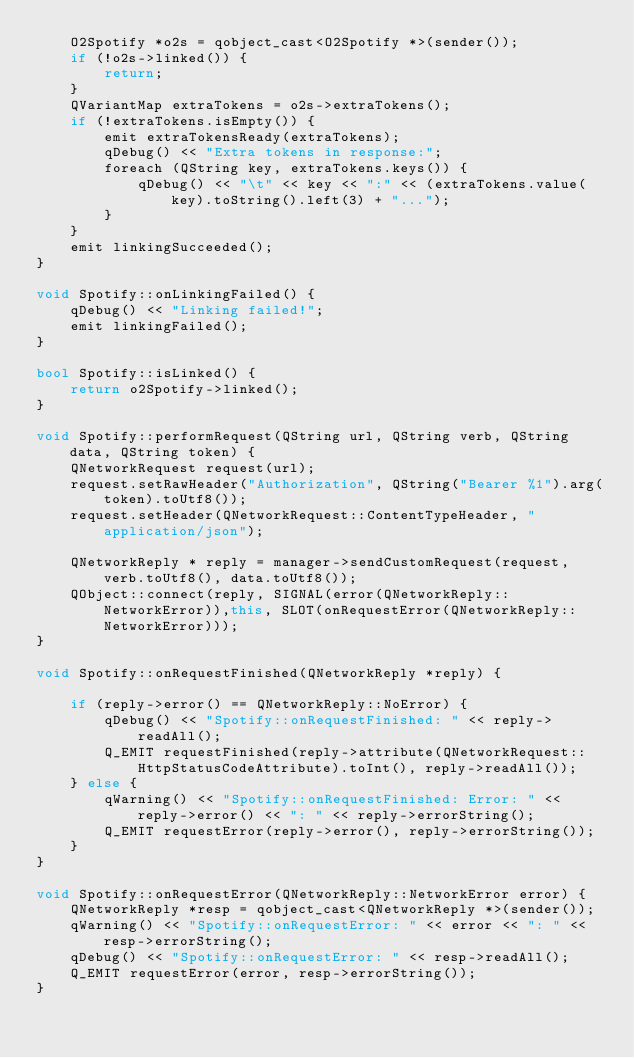Convert code to text. <code><loc_0><loc_0><loc_500><loc_500><_C++_>    O2Spotify *o2s = qobject_cast<O2Spotify *>(sender());
    if (!o2s->linked()) {
        return;
    }
    QVariantMap extraTokens = o2s->extraTokens();
    if (!extraTokens.isEmpty()) {
        emit extraTokensReady(extraTokens);
        qDebug() << "Extra tokens in response:";
        foreach (QString key, extraTokens.keys()) {
            qDebug() << "\t" << key << ":" << (extraTokens.value(key).toString().left(3) + "...");
        }
    }
    emit linkingSucceeded();
}

void Spotify::onLinkingFailed() {
    qDebug() << "Linking failed!";
    emit linkingFailed();
}

bool Spotify::isLinked() {
    return o2Spotify->linked();
}

void Spotify::performRequest(QString url, QString verb, QString data, QString token) {
    QNetworkRequest request(url);
    request.setRawHeader("Authorization", QString("Bearer %1").arg(token).toUtf8());
    request.setHeader(QNetworkRequest::ContentTypeHeader, "application/json");
    
    QNetworkReply * reply = manager->sendCustomRequest(request, verb.toUtf8(), data.toUtf8());
    QObject::connect(reply, SIGNAL(error(QNetworkReply::NetworkError)),this, SLOT(onRequestError(QNetworkReply::NetworkError)));
}

void Spotify::onRequestFinished(QNetworkReply *reply) {

    if (reply->error() == QNetworkReply::NoError) {
        qDebug() << "Spotify::onRequestFinished: " << reply->readAll();
        Q_EMIT requestFinished(reply->attribute(QNetworkRequest::HttpStatusCodeAttribute).toInt(), reply->readAll());
    } else {
        qWarning() << "Spotify::onRequestFinished: Error: " << reply->error() << ": " << reply->errorString();
        Q_EMIT requestError(reply->error(), reply->errorString());
    }
}

void Spotify::onRequestError(QNetworkReply::NetworkError error) { 
    QNetworkReply *resp = qobject_cast<QNetworkReply *>(sender());
    qWarning() << "Spotify::onRequestError: " << error << ": " << resp->errorString();
    qDebug() << "Spotify::onRequestError: " << resp->readAll();
    Q_EMIT requestError(error, resp->errorString());
}
</code> 